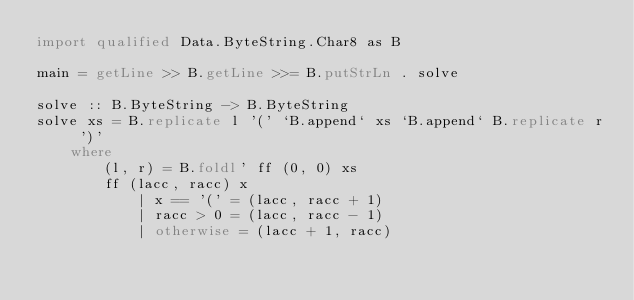<code> <loc_0><loc_0><loc_500><loc_500><_Haskell_>import qualified Data.ByteString.Char8 as B

main = getLine >> B.getLine >>= B.putStrLn . solve

solve :: B.ByteString -> B.ByteString
solve xs = B.replicate l '(' `B.append` xs `B.append` B.replicate r ')'
    where
        (l, r) = B.foldl' ff (0, 0) xs
        ff (lacc, racc) x
            | x == '(' = (lacc, racc + 1)
            | racc > 0 = (lacc, racc - 1)
            | otherwise = (lacc + 1, racc)
</code> 